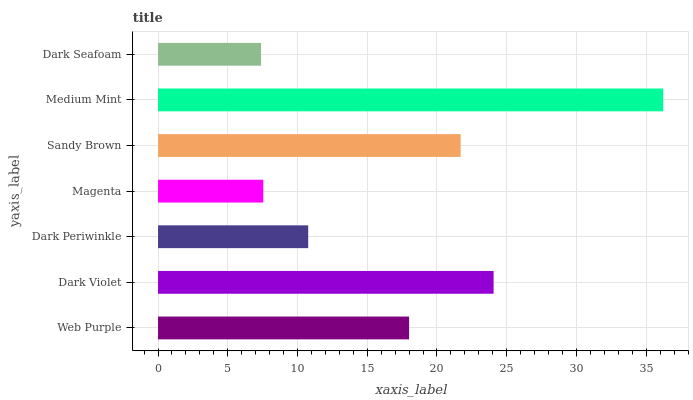Is Dark Seafoam the minimum?
Answer yes or no. Yes. Is Medium Mint the maximum?
Answer yes or no. Yes. Is Dark Violet the minimum?
Answer yes or no. No. Is Dark Violet the maximum?
Answer yes or no. No. Is Dark Violet greater than Web Purple?
Answer yes or no. Yes. Is Web Purple less than Dark Violet?
Answer yes or no. Yes. Is Web Purple greater than Dark Violet?
Answer yes or no. No. Is Dark Violet less than Web Purple?
Answer yes or no. No. Is Web Purple the high median?
Answer yes or no. Yes. Is Web Purple the low median?
Answer yes or no. Yes. Is Dark Violet the high median?
Answer yes or no. No. Is Dark Violet the low median?
Answer yes or no. No. 